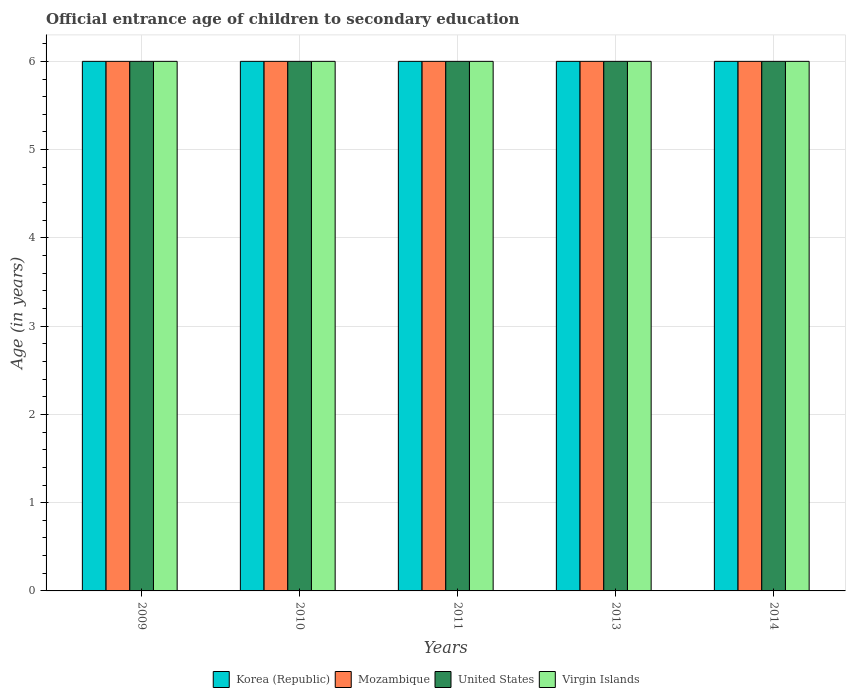How many groups of bars are there?
Provide a succinct answer. 5. Are the number of bars on each tick of the X-axis equal?
Ensure brevity in your answer.  Yes. How many bars are there on the 3rd tick from the left?
Give a very brief answer. 4. How many bars are there on the 2nd tick from the right?
Your answer should be very brief. 4. What is the label of the 3rd group of bars from the left?
Your answer should be compact. 2011. What is the secondary school starting age of children in United States in 2011?
Keep it short and to the point. 6. In which year was the secondary school starting age of children in Korea (Republic) maximum?
Your answer should be very brief. 2009. In which year was the secondary school starting age of children in Virgin Islands minimum?
Offer a very short reply. 2009. What is the total secondary school starting age of children in Korea (Republic) in the graph?
Provide a succinct answer. 30. What is the difference between the secondary school starting age of children in Mozambique in 2014 and the secondary school starting age of children in Virgin Islands in 2009?
Offer a terse response. 0. What is the average secondary school starting age of children in Mozambique per year?
Your answer should be very brief. 6. In the year 2010, what is the difference between the secondary school starting age of children in Korea (Republic) and secondary school starting age of children in Virgin Islands?
Your answer should be very brief. 0. In how many years, is the secondary school starting age of children in United States greater than 2.4 years?
Give a very brief answer. 5. What is the ratio of the secondary school starting age of children in Virgin Islands in 2009 to that in 2010?
Provide a short and direct response. 1. What is the difference between the highest and the second highest secondary school starting age of children in United States?
Offer a terse response. 0. What is the difference between the highest and the lowest secondary school starting age of children in Virgin Islands?
Your answer should be very brief. 0. In how many years, is the secondary school starting age of children in United States greater than the average secondary school starting age of children in United States taken over all years?
Offer a terse response. 0. Is the sum of the secondary school starting age of children in Mozambique in 2009 and 2011 greater than the maximum secondary school starting age of children in Virgin Islands across all years?
Give a very brief answer. Yes. Is it the case that in every year, the sum of the secondary school starting age of children in Virgin Islands and secondary school starting age of children in United States is greater than the sum of secondary school starting age of children in Mozambique and secondary school starting age of children in Korea (Republic)?
Your response must be concise. No. What does the 1st bar from the left in 2011 represents?
Your answer should be compact. Korea (Republic). Is it the case that in every year, the sum of the secondary school starting age of children in Virgin Islands and secondary school starting age of children in Korea (Republic) is greater than the secondary school starting age of children in United States?
Offer a terse response. Yes. How many years are there in the graph?
Keep it short and to the point. 5. What is the title of the graph?
Offer a very short reply. Official entrance age of children to secondary education. Does "Brunei Darussalam" appear as one of the legend labels in the graph?
Make the answer very short. No. What is the label or title of the X-axis?
Your answer should be compact. Years. What is the label or title of the Y-axis?
Ensure brevity in your answer.  Age (in years). What is the Age (in years) in Virgin Islands in 2009?
Provide a short and direct response. 6. What is the Age (in years) in Korea (Republic) in 2010?
Make the answer very short. 6. What is the Age (in years) of Mozambique in 2010?
Offer a terse response. 6. What is the Age (in years) of United States in 2010?
Your response must be concise. 6. What is the Age (in years) in Korea (Republic) in 2011?
Provide a succinct answer. 6. What is the Age (in years) of Mozambique in 2011?
Ensure brevity in your answer.  6. What is the Age (in years) in United States in 2011?
Your answer should be compact. 6. What is the Age (in years) of United States in 2013?
Your answer should be very brief. 6. What is the Age (in years) in Virgin Islands in 2013?
Provide a succinct answer. 6. What is the Age (in years) in Korea (Republic) in 2014?
Your response must be concise. 6. What is the Age (in years) in Mozambique in 2014?
Your answer should be very brief. 6. What is the Age (in years) in United States in 2014?
Provide a short and direct response. 6. What is the Age (in years) in Virgin Islands in 2014?
Provide a succinct answer. 6. Across all years, what is the maximum Age (in years) of Virgin Islands?
Offer a terse response. 6. Across all years, what is the minimum Age (in years) of Korea (Republic)?
Keep it short and to the point. 6. Across all years, what is the minimum Age (in years) of Virgin Islands?
Your response must be concise. 6. What is the total Age (in years) of United States in the graph?
Offer a very short reply. 30. What is the total Age (in years) in Virgin Islands in the graph?
Your response must be concise. 30. What is the difference between the Age (in years) in Korea (Republic) in 2009 and that in 2010?
Your answer should be very brief. 0. What is the difference between the Age (in years) of Mozambique in 2009 and that in 2010?
Give a very brief answer. 0. What is the difference between the Age (in years) in Virgin Islands in 2009 and that in 2010?
Keep it short and to the point. 0. What is the difference between the Age (in years) of Korea (Republic) in 2009 and that in 2011?
Keep it short and to the point. 0. What is the difference between the Age (in years) of Mozambique in 2009 and that in 2011?
Your answer should be very brief. 0. What is the difference between the Age (in years) of United States in 2009 and that in 2011?
Provide a succinct answer. 0. What is the difference between the Age (in years) in Virgin Islands in 2009 and that in 2011?
Your answer should be very brief. 0. What is the difference between the Age (in years) of Korea (Republic) in 2009 and that in 2013?
Offer a terse response. 0. What is the difference between the Age (in years) of Korea (Republic) in 2009 and that in 2014?
Your answer should be very brief. 0. What is the difference between the Age (in years) of Virgin Islands in 2009 and that in 2014?
Your response must be concise. 0. What is the difference between the Age (in years) of Korea (Republic) in 2010 and that in 2011?
Give a very brief answer. 0. What is the difference between the Age (in years) in Mozambique in 2010 and that in 2011?
Ensure brevity in your answer.  0. What is the difference between the Age (in years) in United States in 2010 and that in 2011?
Your response must be concise. 0. What is the difference between the Age (in years) of Virgin Islands in 2010 and that in 2011?
Ensure brevity in your answer.  0. What is the difference between the Age (in years) in Korea (Republic) in 2010 and that in 2013?
Provide a succinct answer. 0. What is the difference between the Age (in years) of United States in 2010 and that in 2013?
Make the answer very short. 0. What is the difference between the Age (in years) of Korea (Republic) in 2010 and that in 2014?
Provide a short and direct response. 0. What is the difference between the Age (in years) of Mozambique in 2010 and that in 2014?
Provide a short and direct response. 0. What is the difference between the Age (in years) of United States in 2010 and that in 2014?
Make the answer very short. 0. What is the difference between the Age (in years) in Virgin Islands in 2010 and that in 2014?
Provide a short and direct response. 0. What is the difference between the Age (in years) of Korea (Republic) in 2011 and that in 2013?
Offer a terse response. 0. What is the difference between the Age (in years) in Mozambique in 2011 and that in 2013?
Keep it short and to the point. 0. What is the difference between the Age (in years) of Virgin Islands in 2011 and that in 2013?
Give a very brief answer. 0. What is the difference between the Age (in years) in Korea (Republic) in 2011 and that in 2014?
Keep it short and to the point. 0. What is the difference between the Age (in years) of Mozambique in 2011 and that in 2014?
Give a very brief answer. 0. What is the difference between the Age (in years) of United States in 2011 and that in 2014?
Ensure brevity in your answer.  0. What is the difference between the Age (in years) of Mozambique in 2013 and that in 2014?
Offer a very short reply. 0. What is the difference between the Age (in years) of United States in 2013 and that in 2014?
Ensure brevity in your answer.  0. What is the difference between the Age (in years) of Virgin Islands in 2013 and that in 2014?
Your answer should be very brief. 0. What is the difference between the Age (in years) in Mozambique in 2009 and the Age (in years) in United States in 2010?
Keep it short and to the point. 0. What is the difference between the Age (in years) of Mozambique in 2009 and the Age (in years) of Virgin Islands in 2010?
Give a very brief answer. 0. What is the difference between the Age (in years) of Korea (Republic) in 2009 and the Age (in years) of Mozambique in 2011?
Keep it short and to the point. 0. What is the difference between the Age (in years) in Korea (Republic) in 2009 and the Age (in years) in United States in 2011?
Your response must be concise. 0. What is the difference between the Age (in years) of Mozambique in 2009 and the Age (in years) of United States in 2011?
Give a very brief answer. 0. What is the difference between the Age (in years) in Mozambique in 2009 and the Age (in years) in Virgin Islands in 2011?
Offer a very short reply. 0. What is the difference between the Age (in years) of Korea (Republic) in 2009 and the Age (in years) of United States in 2013?
Provide a short and direct response. 0. What is the difference between the Age (in years) of Korea (Republic) in 2009 and the Age (in years) of Virgin Islands in 2013?
Ensure brevity in your answer.  0. What is the difference between the Age (in years) in Mozambique in 2009 and the Age (in years) in Virgin Islands in 2013?
Offer a very short reply. 0. What is the difference between the Age (in years) of Korea (Republic) in 2009 and the Age (in years) of Mozambique in 2014?
Your response must be concise. 0. What is the difference between the Age (in years) in Korea (Republic) in 2009 and the Age (in years) in United States in 2014?
Your response must be concise. 0. What is the difference between the Age (in years) of Mozambique in 2009 and the Age (in years) of United States in 2014?
Give a very brief answer. 0. What is the difference between the Age (in years) in Mozambique in 2009 and the Age (in years) in Virgin Islands in 2014?
Your answer should be compact. 0. What is the difference between the Age (in years) of Korea (Republic) in 2010 and the Age (in years) of United States in 2011?
Make the answer very short. 0. What is the difference between the Age (in years) of Korea (Republic) in 2010 and the Age (in years) of Virgin Islands in 2011?
Give a very brief answer. 0. What is the difference between the Age (in years) of Mozambique in 2010 and the Age (in years) of Virgin Islands in 2011?
Your answer should be very brief. 0. What is the difference between the Age (in years) in United States in 2010 and the Age (in years) in Virgin Islands in 2011?
Your answer should be very brief. 0. What is the difference between the Age (in years) in Korea (Republic) in 2010 and the Age (in years) in Mozambique in 2013?
Your answer should be very brief. 0. What is the difference between the Age (in years) of Korea (Republic) in 2010 and the Age (in years) of United States in 2013?
Your answer should be very brief. 0. What is the difference between the Age (in years) of Korea (Republic) in 2010 and the Age (in years) of Virgin Islands in 2013?
Your answer should be compact. 0. What is the difference between the Age (in years) of Mozambique in 2010 and the Age (in years) of Virgin Islands in 2013?
Offer a very short reply. 0. What is the difference between the Age (in years) in Mozambique in 2010 and the Age (in years) in Virgin Islands in 2014?
Make the answer very short. 0. What is the difference between the Age (in years) in United States in 2010 and the Age (in years) in Virgin Islands in 2014?
Provide a succinct answer. 0. What is the difference between the Age (in years) of Korea (Republic) in 2011 and the Age (in years) of Mozambique in 2013?
Your answer should be compact. 0. What is the difference between the Age (in years) in Korea (Republic) in 2011 and the Age (in years) in United States in 2013?
Provide a succinct answer. 0. What is the difference between the Age (in years) of Korea (Republic) in 2011 and the Age (in years) of Virgin Islands in 2013?
Offer a very short reply. 0. What is the difference between the Age (in years) in Korea (Republic) in 2011 and the Age (in years) in Mozambique in 2014?
Offer a terse response. 0. What is the difference between the Age (in years) of Korea (Republic) in 2011 and the Age (in years) of Virgin Islands in 2014?
Provide a succinct answer. 0. What is the difference between the Age (in years) of Mozambique in 2011 and the Age (in years) of United States in 2014?
Your answer should be compact. 0. What is the difference between the Age (in years) of Korea (Republic) in 2013 and the Age (in years) of United States in 2014?
Give a very brief answer. 0. What is the difference between the Age (in years) in Korea (Republic) in 2013 and the Age (in years) in Virgin Islands in 2014?
Your answer should be compact. 0. What is the difference between the Age (in years) in Mozambique in 2013 and the Age (in years) in United States in 2014?
Your response must be concise. 0. What is the difference between the Age (in years) of Mozambique in 2013 and the Age (in years) of Virgin Islands in 2014?
Provide a short and direct response. 0. What is the difference between the Age (in years) of United States in 2013 and the Age (in years) of Virgin Islands in 2014?
Provide a succinct answer. 0. What is the average Age (in years) of Korea (Republic) per year?
Keep it short and to the point. 6. What is the average Age (in years) in Virgin Islands per year?
Keep it short and to the point. 6. In the year 2009, what is the difference between the Age (in years) in Korea (Republic) and Age (in years) in United States?
Make the answer very short. 0. In the year 2009, what is the difference between the Age (in years) in Mozambique and Age (in years) in Virgin Islands?
Your response must be concise. 0. In the year 2009, what is the difference between the Age (in years) of United States and Age (in years) of Virgin Islands?
Your answer should be very brief. 0. In the year 2010, what is the difference between the Age (in years) in Korea (Republic) and Age (in years) in Virgin Islands?
Provide a succinct answer. 0. In the year 2010, what is the difference between the Age (in years) of United States and Age (in years) of Virgin Islands?
Give a very brief answer. 0. In the year 2011, what is the difference between the Age (in years) of Korea (Republic) and Age (in years) of Virgin Islands?
Give a very brief answer. 0. In the year 2011, what is the difference between the Age (in years) of Mozambique and Age (in years) of United States?
Make the answer very short. 0. In the year 2013, what is the difference between the Age (in years) of Korea (Republic) and Age (in years) of Mozambique?
Offer a very short reply. 0. In the year 2013, what is the difference between the Age (in years) in Korea (Republic) and Age (in years) in United States?
Your response must be concise. 0. In the year 2013, what is the difference between the Age (in years) in Mozambique and Age (in years) in Virgin Islands?
Make the answer very short. 0. In the year 2013, what is the difference between the Age (in years) of United States and Age (in years) of Virgin Islands?
Offer a terse response. 0. In the year 2014, what is the difference between the Age (in years) in Korea (Republic) and Age (in years) in United States?
Offer a very short reply. 0. In the year 2014, what is the difference between the Age (in years) in Mozambique and Age (in years) in Virgin Islands?
Your response must be concise. 0. In the year 2014, what is the difference between the Age (in years) of United States and Age (in years) of Virgin Islands?
Offer a very short reply. 0. What is the ratio of the Age (in years) of Korea (Republic) in 2009 to that in 2010?
Make the answer very short. 1. What is the ratio of the Age (in years) in United States in 2009 to that in 2010?
Offer a terse response. 1. What is the ratio of the Age (in years) in Korea (Republic) in 2009 to that in 2011?
Offer a terse response. 1. What is the ratio of the Age (in years) in Mozambique in 2009 to that in 2011?
Provide a succinct answer. 1. What is the ratio of the Age (in years) in United States in 2009 to that in 2011?
Make the answer very short. 1. What is the ratio of the Age (in years) of United States in 2009 to that in 2013?
Give a very brief answer. 1. What is the ratio of the Age (in years) of Virgin Islands in 2009 to that in 2013?
Keep it short and to the point. 1. What is the ratio of the Age (in years) in Mozambique in 2009 to that in 2014?
Your answer should be compact. 1. What is the ratio of the Age (in years) of United States in 2009 to that in 2014?
Offer a very short reply. 1. What is the ratio of the Age (in years) of Korea (Republic) in 2010 to that in 2011?
Ensure brevity in your answer.  1. What is the ratio of the Age (in years) in Mozambique in 2010 to that in 2011?
Provide a succinct answer. 1. What is the ratio of the Age (in years) in United States in 2010 to that in 2011?
Offer a very short reply. 1. What is the ratio of the Age (in years) of Virgin Islands in 2010 to that in 2011?
Keep it short and to the point. 1. What is the ratio of the Age (in years) in Mozambique in 2010 to that in 2013?
Provide a succinct answer. 1. What is the ratio of the Age (in years) of United States in 2010 to that in 2013?
Give a very brief answer. 1. What is the ratio of the Age (in years) of Virgin Islands in 2010 to that in 2013?
Provide a succinct answer. 1. What is the ratio of the Age (in years) of Virgin Islands in 2010 to that in 2014?
Make the answer very short. 1. What is the ratio of the Age (in years) of Mozambique in 2011 to that in 2013?
Keep it short and to the point. 1. What is the ratio of the Age (in years) in Virgin Islands in 2011 to that in 2013?
Provide a short and direct response. 1. What is the ratio of the Age (in years) in Mozambique in 2011 to that in 2014?
Keep it short and to the point. 1. What is the ratio of the Age (in years) in United States in 2013 to that in 2014?
Your response must be concise. 1. What is the difference between the highest and the second highest Age (in years) in Korea (Republic)?
Provide a succinct answer. 0. What is the difference between the highest and the lowest Age (in years) of United States?
Offer a terse response. 0. What is the difference between the highest and the lowest Age (in years) in Virgin Islands?
Provide a short and direct response. 0. 